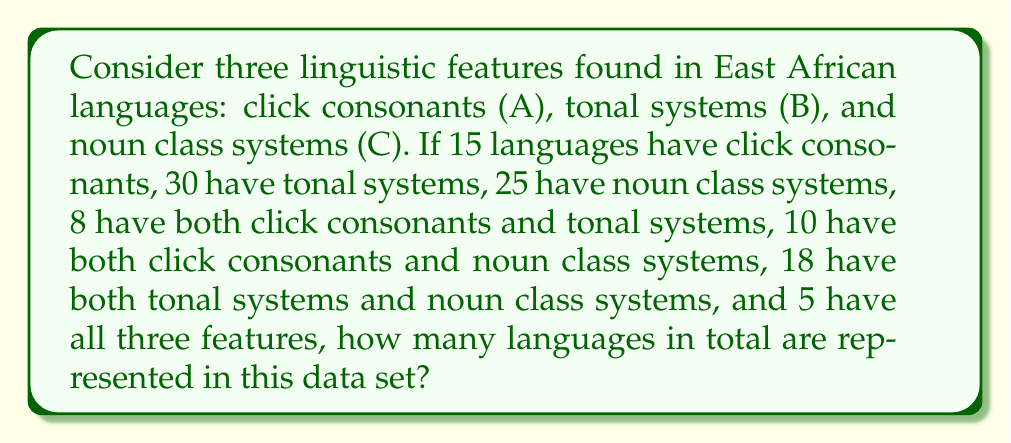Could you help me with this problem? Let's approach this step-by-step using the principle of inclusion-exclusion:

1) First, let's define our sets:
   A: Languages with click consonants
   B: Languages with tonal systems
   C: Languages with noun class systems

2) We're given:
   $|A| = 15$, $|B| = 30$, $|C| = 25$
   $|A \cap B| = 8$, $|A \cap C| = 10$, $|B \cap C| = 18$
   $|A \cap B \cap C| = 5$

3) The formula for the union of three sets is:
   $$|A \cup B \cup C| = |A| + |B| + |C| - |A \cap B| - |A \cap C| - |B \cap C| + |A \cap B \cap C|$$

4) Let's substitute our values:
   $$|A \cup B \cup C| = 15 + 30 + 25 - 8 - 10 - 18 + 5$$

5) Now we can calculate:
   $$|A \cup B \cup C| = 70 - 36 + 5 = 39$$

Therefore, there are 39 languages represented in this data set.
Answer: 39 